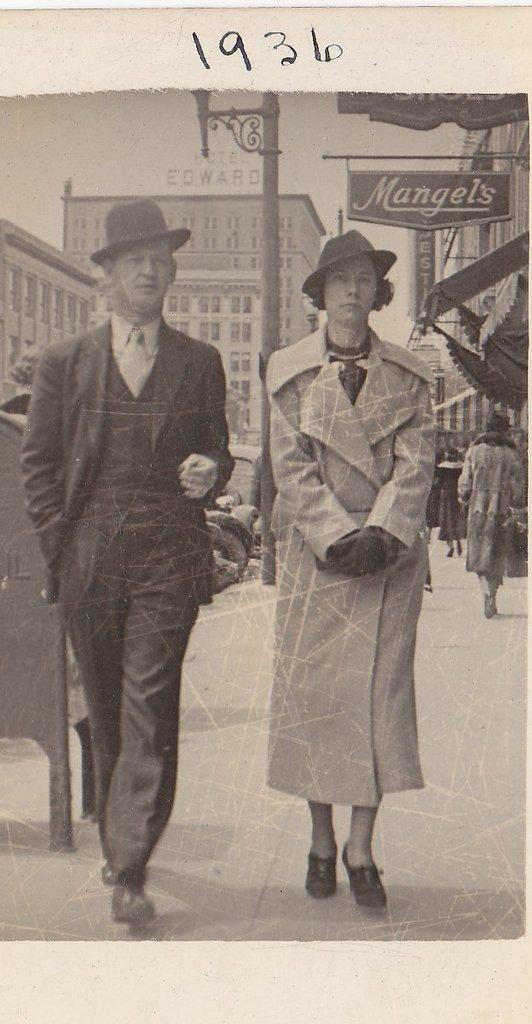How would you summarize this image in a sentence or two? This is an old black and white image. I can see few people standing on the pathway. In the background, there are buildings, name board, pole and an object. At the top of the image, I can see the numbers. 